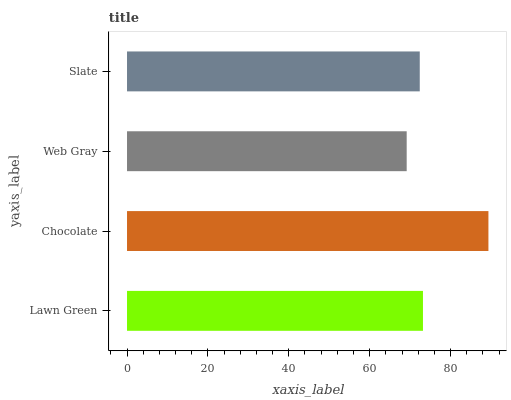Is Web Gray the minimum?
Answer yes or no. Yes. Is Chocolate the maximum?
Answer yes or no. Yes. Is Chocolate the minimum?
Answer yes or no. No. Is Web Gray the maximum?
Answer yes or no. No. Is Chocolate greater than Web Gray?
Answer yes or no. Yes. Is Web Gray less than Chocolate?
Answer yes or no. Yes. Is Web Gray greater than Chocolate?
Answer yes or no. No. Is Chocolate less than Web Gray?
Answer yes or no. No. Is Lawn Green the high median?
Answer yes or no. Yes. Is Slate the low median?
Answer yes or no. Yes. Is Slate the high median?
Answer yes or no. No. Is Lawn Green the low median?
Answer yes or no. No. 